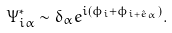Convert formula to latex. <formula><loc_0><loc_0><loc_500><loc_500>\Psi _ { i \alpha } ^ { \ast } \sim \delta _ { \alpha } e ^ { i ( \phi _ { i } + \phi _ { i + \hat { e } _ { \alpha } } ) } .</formula> 